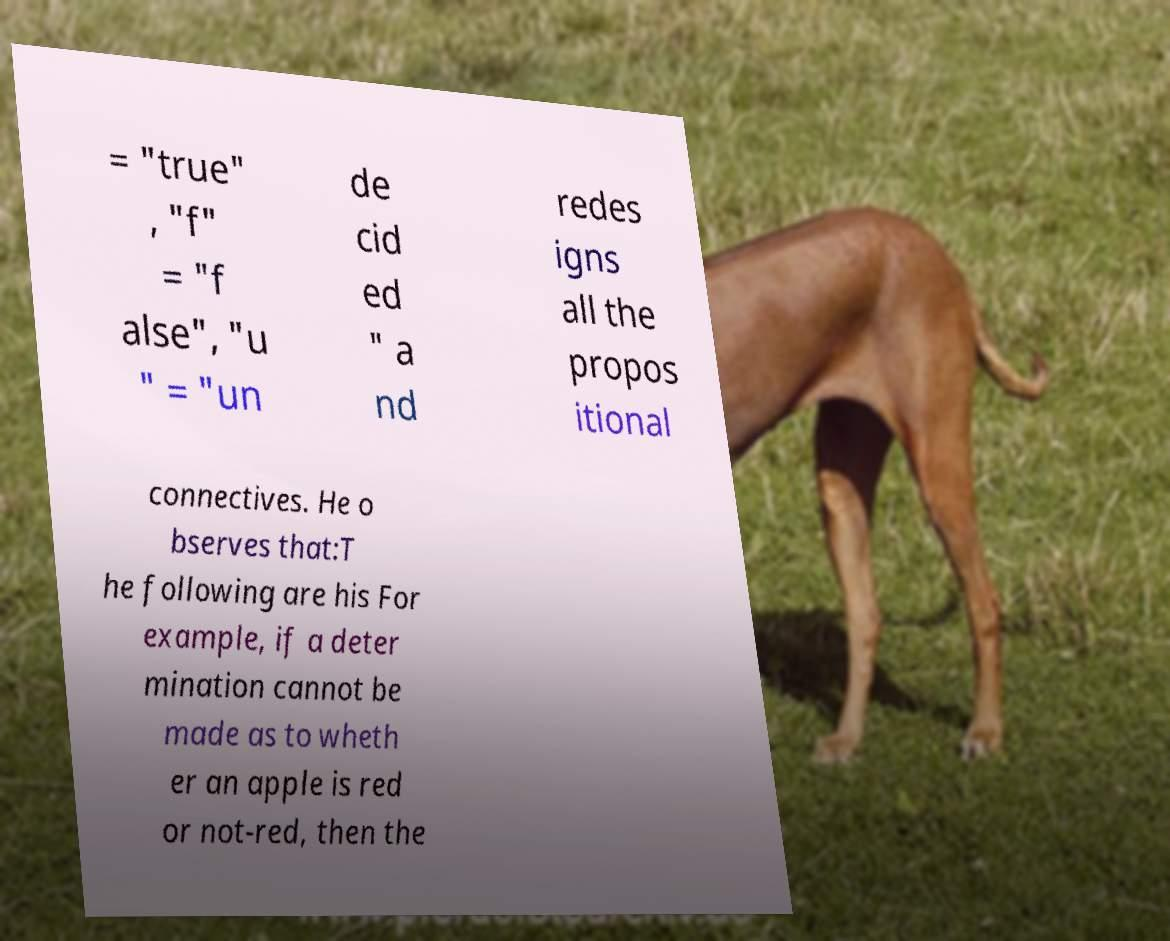For documentation purposes, I need the text within this image transcribed. Could you provide that? = "true" , "f" = "f alse", "u " = "un de cid ed " a nd redes igns all the propos itional connectives. He o bserves that:T he following are his For example, if a deter mination cannot be made as to wheth er an apple is red or not-red, then the 